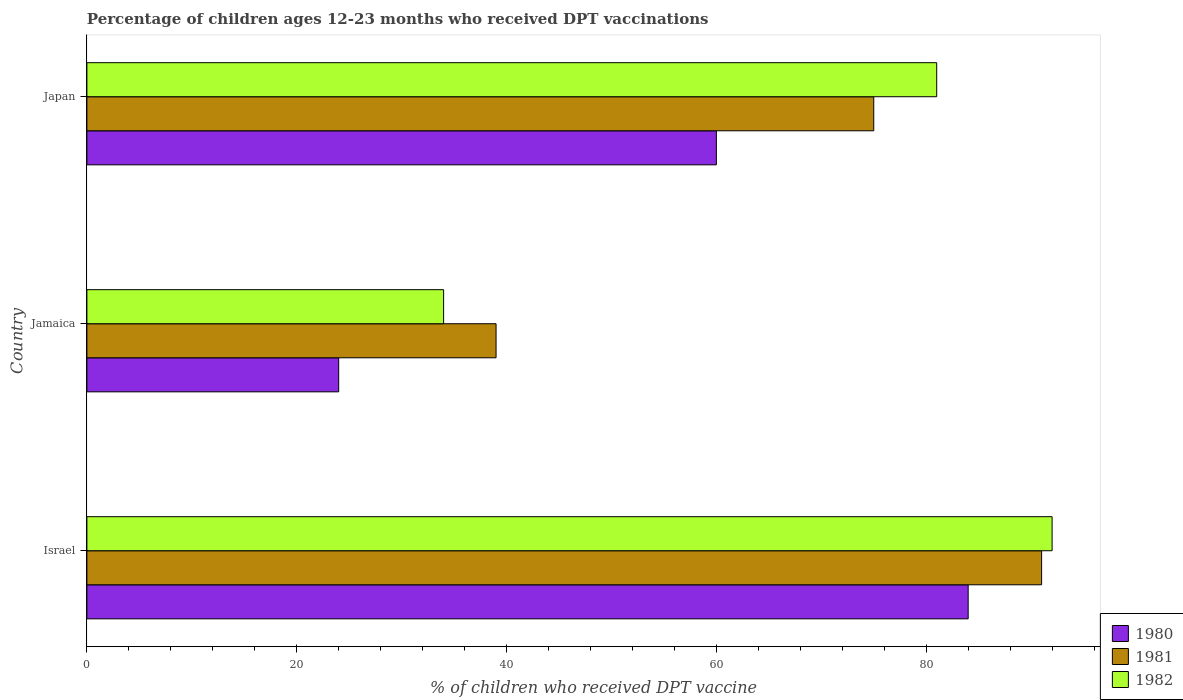How many different coloured bars are there?
Your response must be concise. 3. Are the number of bars on each tick of the Y-axis equal?
Provide a succinct answer. Yes. How many bars are there on the 3rd tick from the bottom?
Offer a terse response. 3. What is the label of the 2nd group of bars from the top?
Your answer should be very brief. Jamaica. In how many cases, is the number of bars for a given country not equal to the number of legend labels?
Make the answer very short. 0. Across all countries, what is the maximum percentage of children who received DPT vaccination in 1982?
Offer a terse response. 92. Across all countries, what is the minimum percentage of children who received DPT vaccination in 1980?
Make the answer very short. 24. In which country was the percentage of children who received DPT vaccination in 1981 maximum?
Keep it short and to the point. Israel. In which country was the percentage of children who received DPT vaccination in 1981 minimum?
Ensure brevity in your answer.  Jamaica. What is the total percentage of children who received DPT vaccination in 1980 in the graph?
Make the answer very short. 168. What is the difference between the percentage of children who received DPT vaccination in 1980 in Jamaica and that in Japan?
Provide a succinct answer. -36. What is the average percentage of children who received DPT vaccination in 1982 per country?
Provide a short and direct response. 69. What is the difference between the percentage of children who received DPT vaccination in 1982 and percentage of children who received DPT vaccination in 1981 in Japan?
Offer a very short reply. 6. Is the difference between the percentage of children who received DPT vaccination in 1982 in Israel and Japan greater than the difference between the percentage of children who received DPT vaccination in 1981 in Israel and Japan?
Your answer should be compact. No. What is the difference between the highest and the lowest percentage of children who received DPT vaccination in 1981?
Ensure brevity in your answer.  52. What does the 3rd bar from the top in Japan represents?
Offer a very short reply. 1980. What is the difference between two consecutive major ticks on the X-axis?
Provide a succinct answer. 20. Are the values on the major ticks of X-axis written in scientific E-notation?
Provide a succinct answer. No. Does the graph contain grids?
Provide a succinct answer. No. How many legend labels are there?
Offer a terse response. 3. How are the legend labels stacked?
Offer a terse response. Vertical. What is the title of the graph?
Provide a short and direct response. Percentage of children ages 12-23 months who received DPT vaccinations. What is the label or title of the X-axis?
Your answer should be very brief. % of children who received DPT vaccine. What is the label or title of the Y-axis?
Provide a succinct answer. Country. What is the % of children who received DPT vaccine in 1981 in Israel?
Your response must be concise. 91. What is the % of children who received DPT vaccine of 1982 in Israel?
Provide a succinct answer. 92. What is the % of children who received DPT vaccine in 1981 in Jamaica?
Give a very brief answer. 39. What is the % of children who received DPT vaccine of 1982 in Jamaica?
Give a very brief answer. 34. What is the % of children who received DPT vaccine in 1980 in Japan?
Give a very brief answer. 60. What is the % of children who received DPT vaccine of 1981 in Japan?
Your answer should be compact. 75. Across all countries, what is the maximum % of children who received DPT vaccine of 1981?
Provide a succinct answer. 91. Across all countries, what is the maximum % of children who received DPT vaccine in 1982?
Give a very brief answer. 92. Across all countries, what is the minimum % of children who received DPT vaccine of 1980?
Make the answer very short. 24. Across all countries, what is the minimum % of children who received DPT vaccine of 1981?
Make the answer very short. 39. Across all countries, what is the minimum % of children who received DPT vaccine in 1982?
Keep it short and to the point. 34. What is the total % of children who received DPT vaccine in 1980 in the graph?
Ensure brevity in your answer.  168. What is the total % of children who received DPT vaccine in 1981 in the graph?
Offer a terse response. 205. What is the total % of children who received DPT vaccine of 1982 in the graph?
Your answer should be compact. 207. What is the difference between the % of children who received DPT vaccine in 1981 in Israel and that in Jamaica?
Ensure brevity in your answer.  52. What is the difference between the % of children who received DPT vaccine of 1981 in Israel and that in Japan?
Your response must be concise. 16. What is the difference between the % of children who received DPT vaccine of 1980 in Jamaica and that in Japan?
Your answer should be compact. -36. What is the difference between the % of children who received DPT vaccine in 1981 in Jamaica and that in Japan?
Your answer should be very brief. -36. What is the difference between the % of children who received DPT vaccine in 1982 in Jamaica and that in Japan?
Offer a very short reply. -47. What is the difference between the % of children who received DPT vaccine in 1980 in Israel and the % of children who received DPT vaccine in 1982 in Jamaica?
Keep it short and to the point. 50. What is the difference between the % of children who received DPT vaccine of 1980 in Israel and the % of children who received DPT vaccine of 1981 in Japan?
Your answer should be very brief. 9. What is the difference between the % of children who received DPT vaccine in 1981 in Israel and the % of children who received DPT vaccine in 1982 in Japan?
Keep it short and to the point. 10. What is the difference between the % of children who received DPT vaccine of 1980 in Jamaica and the % of children who received DPT vaccine of 1981 in Japan?
Your answer should be very brief. -51. What is the difference between the % of children who received DPT vaccine in 1980 in Jamaica and the % of children who received DPT vaccine in 1982 in Japan?
Offer a terse response. -57. What is the difference between the % of children who received DPT vaccine in 1981 in Jamaica and the % of children who received DPT vaccine in 1982 in Japan?
Your answer should be compact. -42. What is the average % of children who received DPT vaccine of 1981 per country?
Make the answer very short. 68.33. What is the difference between the % of children who received DPT vaccine of 1981 and % of children who received DPT vaccine of 1982 in Israel?
Provide a succinct answer. -1. What is the difference between the % of children who received DPT vaccine in 1980 and % of children who received DPT vaccine in 1981 in Jamaica?
Make the answer very short. -15. What is the difference between the % of children who received DPT vaccine of 1981 and % of children who received DPT vaccine of 1982 in Jamaica?
Your answer should be compact. 5. What is the difference between the % of children who received DPT vaccine in 1980 and % of children who received DPT vaccine in 1981 in Japan?
Provide a short and direct response. -15. What is the ratio of the % of children who received DPT vaccine of 1980 in Israel to that in Jamaica?
Make the answer very short. 3.5. What is the ratio of the % of children who received DPT vaccine of 1981 in Israel to that in Jamaica?
Give a very brief answer. 2.33. What is the ratio of the % of children who received DPT vaccine of 1982 in Israel to that in Jamaica?
Your response must be concise. 2.71. What is the ratio of the % of children who received DPT vaccine in 1980 in Israel to that in Japan?
Provide a short and direct response. 1.4. What is the ratio of the % of children who received DPT vaccine in 1981 in Israel to that in Japan?
Make the answer very short. 1.21. What is the ratio of the % of children who received DPT vaccine of 1982 in Israel to that in Japan?
Your answer should be very brief. 1.14. What is the ratio of the % of children who received DPT vaccine in 1981 in Jamaica to that in Japan?
Your answer should be very brief. 0.52. What is the ratio of the % of children who received DPT vaccine of 1982 in Jamaica to that in Japan?
Ensure brevity in your answer.  0.42. What is the difference between the highest and the second highest % of children who received DPT vaccine in 1980?
Offer a very short reply. 24. What is the difference between the highest and the second highest % of children who received DPT vaccine of 1981?
Your response must be concise. 16. 